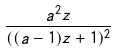Convert formula to latex. <formula><loc_0><loc_0><loc_500><loc_500>\frac { a ^ { 2 } z } { ( ( a - 1 ) z + 1 ) ^ { 2 } }</formula> 